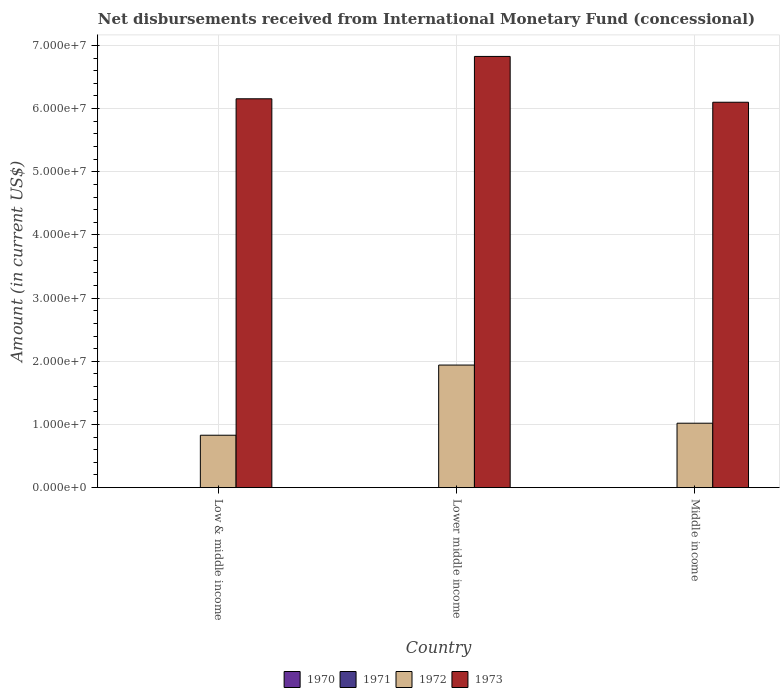Are the number of bars on each tick of the X-axis equal?
Make the answer very short. Yes. What is the label of the 1st group of bars from the left?
Your response must be concise. Low & middle income. In how many cases, is the number of bars for a given country not equal to the number of legend labels?
Ensure brevity in your answer.  3. What is the amount of disbursements received from International Monetary Fund in 1972 in Low & middle income?
Your answer should be very brief. 8.30e+06. Across all countries, what is the maximum amount of disbursements received from International Monetary Fund in 1973?
Provide a succinct answer. 6.83e+07. Across all countries, what is the minimum amount of disbursements received from International Monetary Fund in 1970?
Give a very brief answer. 0. In which country was the amount of disbursements received from International Monetary Fund in 1972 maximum?
Provide a succinct answer. Lower middle income. What is the total amount of disbursements received from International Monetary Fund in 1973 in the graph?
Your answer should be compact. 1.91e+08. What is the difference between the amount of disbursements received from International Monetary Fund in 1972 in Low & middle income and that in Middle income?
Make the answer very short. -1.90e+06. What is the difference between the amount of disbursements received from International Monetary Fund in 1972 in Lower middle income and the amount of disbursements received from International Monetary Fund in 1971 in Low & middle income?
Ensure brevity in your answer.  1.94e+07. What is the average amount of disbursements received from International Monetary Fund in 1971 per country?
Ensure brevity in your answer.  0. What is the difference between the amount of disbursements received from International Monetary Fund of/in 1972 and amount of disbursements received from International Monetary Fund of/in 1973 in Low & middle income?
Your response must be concise. -5.33e+07. What is the ratio of the amount of disbursements received from International Monetary Fund in 1973 in Low & middle income to that in Middle income?
Make the answer very short. 1.01. Is the difference between the amount of disbursements received from International Monetary Fund in 1972 in Lower middle income and Middle income greater than the difference between the amount of disbursements received from International Monetary Fund in 1973 in Lower middle income and Middle income?
Provide a short and direct response. Yes. What is the difference between the highest and the second highest amount of disbursements received from International Monetary Fund in 1973?
Your response must be concise. -7.25e+06. What is the difference between the highest and the lowest amount of disbursements received from International Monetary Fund in 1973?
Your answer should be compact. 7.25e+06. Is the sum of the amount of disbursements received from International Monetary Fund in 1972 in Low & middle income and Middle income greater than the maximum amount of disbursements received from International Monetary Fund in 1970 across all countries?
Your response must be concise. Yes. Is it the case that in every country, the sum of the amount of disbursements received from International Monetary Fund in 1971 and amount of disbursements received from International Monetary Fund in 1972 is greater than the sum of amount of disbursements received from International Monetary Fund in 1970 and amount of disbursements received from International Monetary Fund in 1973?
Provide a short and direct response. No. How many bars are there?
Provide a short and direct response. 6. What is the difference between two consecutive major ticks on the Y-axis?
Make the answer very short. 1.00e+07. Are the values on the major ticks of Y-axis written in scientific E-notation?
Ensure brevity in your answer.  Yes. How many legend labels are there?
Provide a short and direct response. 4. How are the legend labels stacked?
Provide a succinct answer. Horizontal. What is the title of the graph?
Give a very brief answer. Net disbursements received from International Monetary Fund (concessional). What is the Amount (in current US$) of 1972 in Low & middle income?
Your answer should be compact. 8.30e+06. What is the Amount (in current US$) in 1973 in Low & middle income?
Your answer should be compact. 6.16e+07. What is the Amount (in current US$) in 1972 in Lower middle income?
Ensure brevity in your answer.  1.94e+07. What is the Amount (in current US$) in 1973 in Lower middle income?
Keep it short and to the point. 6.83e+07. What is the Amount (in current US$) in 1970 in Middle income?
Offer a very short reply. 0. What is the Amount (in current US$) in 1972 in Middle income?
Provide a succinct answer. 1.02e+07. What is the Amount (in current US$) in 1973 in Middle income?
Keep it short and to the point. 6.10e+07. Across all countries, what is the maximum Amount (in current US$) of 1972?
Your answer should be compact. 1.94e+07. Across all countries, what is the maximum Amount (in current US$) in 1973?
Your response must be concise. 6.83e+07. Across all countries, what is the minimum Amount (in current US$) of 1972?
Provide a short and direct response. 8.30e+06. Across all countries, what is the minimum Amount (in current US$) of 1973?
Make the answer very short. 6.10e+07. What is the total Amount (in current US$) in 1972 in the graph?
Make the answer very short. 3.79e+07. What is the total Amount (in current US$) in 1973 in the graph?
Your answer should be compact. 1.91e+08. What is the difference between the Amount (in current US$) in 1972 in Low & middle income and that in Lower middle income?
Keep it short and to the point. -1.11e+07. What is the difference between the Amount (in current US$) in 1973 in Low & middle income and that in Lower middle income?
Your response must be concise. -6.70e+06. What is the difference between the Amount (in current US$) of 1972 in Low & middle income and that in Middle income?
Keep it short and to the point. -1.90e+06. What is the difference between the Amount (in current US$) in 1973 in Low & middle income and that in Middle income?
Give a very brief answer. 5.46e+05. What is the difference between the Amount (in current US$) in 1972 in Lower middle income and that in Middle income?
Offer a terse response. 9.21e+06. What is the difference between the Amount (in current US$) in 1973 in Lower middle income and that in Middle income?
Provide a succinct answer. 7.25e+06. What is the difference between the Amount (in current US$) in 1972 in Low & middle income and the Amount (in current US$) in 1973 in Lower middle income?
Your answer should be very brief. -6.00e+07. What is the difference between the Amount (in current US$) in 1972 in Low & middle income and the Amount (in current US$) in 1973 in Middle income?
Your answer should be compact. -5.27e+07. What is the difference between the Amount (in current US$) in 1972 in Lower middle income and the Amount (in current US$) in 1973 in Middle income?
Ensure brevity in your answer.  -4.16e+07. What is the average Amount (in current US$) in 1970 per country?
Keep it short and to the point. 0. What is the average Amount (in current US$) of 1971 per country?
Ensure brevity in your answer.  0. What is the average Amount (in current US$) in 1972 per country?
Keep it short and to the point. 1.26e+07. What is the average Amount (in current US$) of 1973 per country?
Give a very brief answer. 6.36e+07. What is the difference between the Amount (in current US$) of 1972 and Amount (in current US$) of 1973 in Low & middle income?
Your answer should be compact. -5.33e+07. What is the difference between the Amount (in current US$) in 1972 and Amount (in current US$) in 1973 in Lower middle income?
Your response must be concise. -4.89e+07. What is the difference between the Amount (in current US$) in 1972 and Amount (in current US$) in 1973 in Middle income?
Your response must be concise. -5.08e+07. What is the ratio of the Amount (in current US$) of 1972 in Low & middle income to that in Lower middle income?
Provide a short and direct response. 0.43. What is the ratio of the Amount (in current US$) in 1973 in Low & middle income to that in Lower middle income?
Your answer should be very brief. 0.9. What is the ratio of the Amount (in current US$) of 1972 in Low & middle income to that in Middle income?
Give a very brief answer. 0.81. What is the ratio of the Amount (in current US$) of 1972 in Lower middle income to that in Middle income?
Provide a succinct answer. 1.9. What is the ratio of the Amount (in current US$) of 1973 in Lower middle income to that in Middle income?
Ensure brevity in your answer.  1.12. What is the difference between the highest and the second highest Amount (in current US$) in 1972?
Your answer should be compact. 9.21e+06. What is the difference between the highest and the second highest Amount (in current US$) in 1973?
Make the answer very short. 6.70e+06. What is the difference between the highest and the lowest Amount (in current US$) in 1972?
Provide a short and direct response. 1.11e+07. What is the difference between the highest and the lowest Amount (in current US$) in 1973?
Provide a short and direct response. 7.25e+06. 